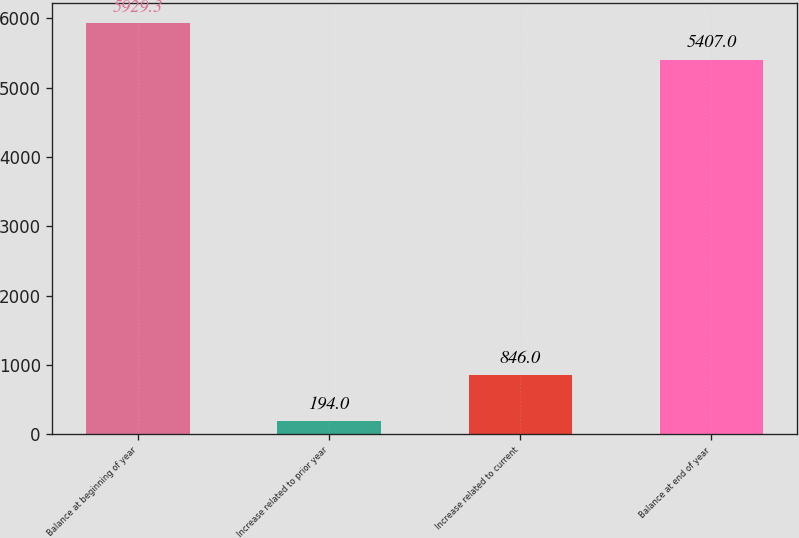Convert chart. <chart><loc_0><loc_0><loc_500><loc_500><bar_chart><fcel>Balance at beginning of year<fcel>Increase related to prior year<fcel>Increase related to current<fcel>Balance at end of year<nl><fcel>5929.3<fcel>194<fcel>846<fcel>5407<nl></chart> 